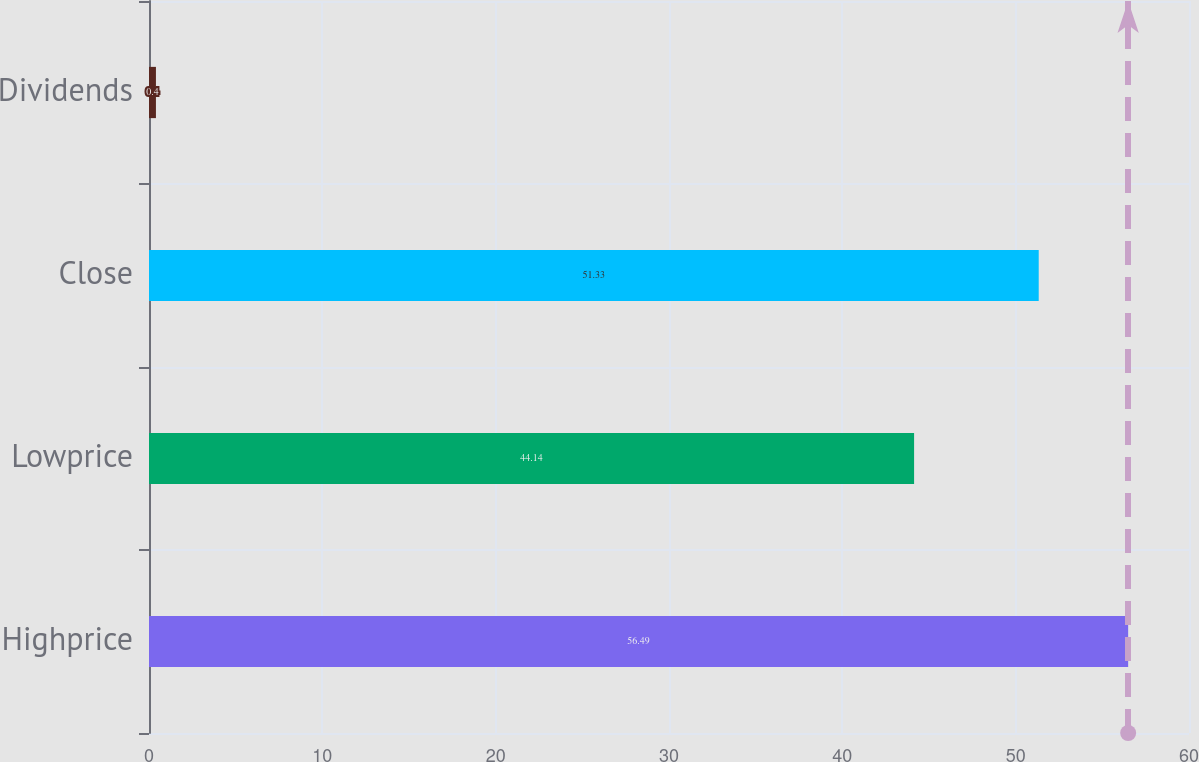<chart> <loc_0><loc_0><loc_500><loc_500><bar_chart><fcel>Highprice<fcel>Lowprice<fcel>Close<fcel>Dividends<nl><fcel>56.49<fcel>44.14<fcel>51.33<fcel>0.4<nl></chart> 